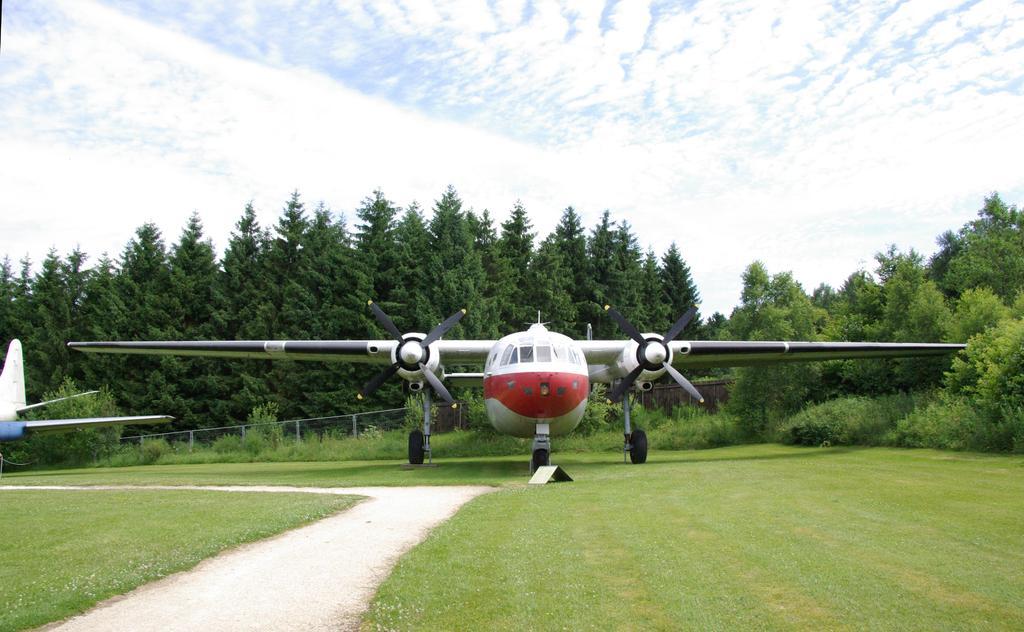Could you give a brief overview of what you see in this image? This is an outside view. At the bottom there is a path, on both sides I can see the grass. In the middle of the image there are two airplanes on the ground. In the background there are many trees. At the top of the image I can see the sky and clouds. 